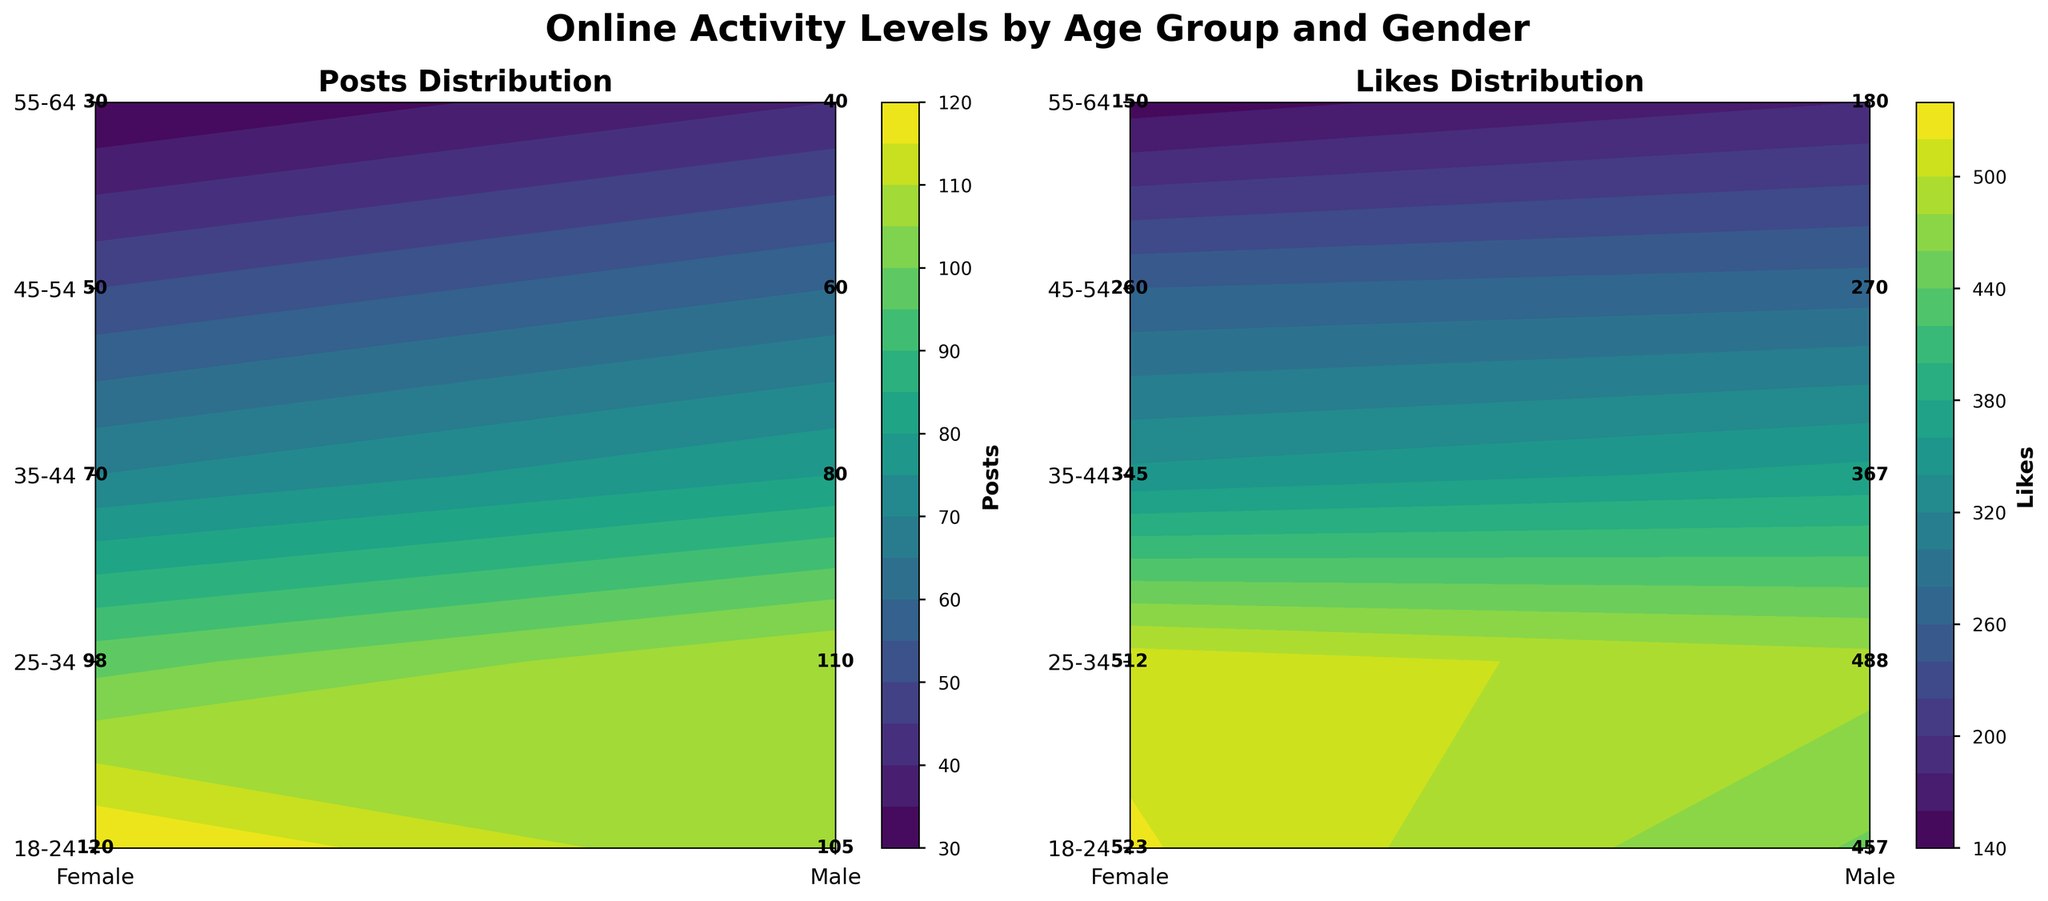What is the title of the figure? The title is displayed at the top center of the plot, summarizing the content of the figure. It reads "Online Activity Levels by Age Group and Gender".
Answer: Online Activity Levels by Age Group and Gender Which age group has the highest number of posts for females? From the contour plot on the left side, we observe the highest value in the 'Posts' distribution for females occurs at the age group '18-24'. By checking the specific labeled values, we verify that '18-24' age group females have the highest number of posts, which is 120.
Answer: 18-24 Between males and females, who received the most likes in the '35-44' age group? In the contour plot on the right side depicting 'Likes' distribution, locate the '35-44' age group on the y-axis and compare the values for both genders. The number of likes for females is 345, and for males, it is 367.
Answer: Males What is the combined total of comments made by the '25-34' age group for both genders? Identify the comments for both genders in the '25-34' age group from the figure. Females have 125 comments, and males have 140 comments in this age group. Summing them: 125 + 140 = 265.
Answer: 265 Are the number of posts higher for males or females in the 45-54 age group? Locate the '45-54' age group on the left ('Posts') plot. Compare the values for males and females. Females have 50 posts, whereas males have 60 posts.
Answer: Males Which metric (Posts or Likes) shows a higher value for males in the '55-64' age group? Compare the values for males in the '55-64' age group in both contour plots. In the 'Posts' plot, males have 40 posts, and in the 'Likes' plot, they have 180 likes. Since 180 > 40, the 'Likes' metric shows a higher value.
Answer: Likes What is the difference in the number of likes between males and females in the '18-24' age group? From the 'Likes' distribution plot, determine the values for males and females in the '18-24' age group: 457 for males and 523 for females. The difference is 523 - 457 = 66.
Answer: 66 Among all the 'Posts' metrics shown, which gender and age group combination have the highest activity? Compare the 'Posts' values across all gender and age group combinations in the contour plot. The highest value is 120, which is for females in the '18-24' age group.
Answer: Female, 18-24 